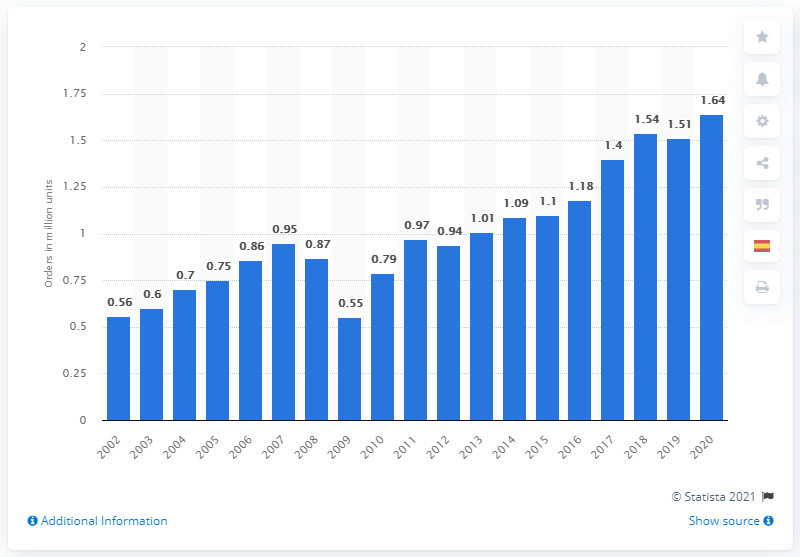Identify some key points in this picture. In 2020, there were 1.64 new industrial truck orders. 